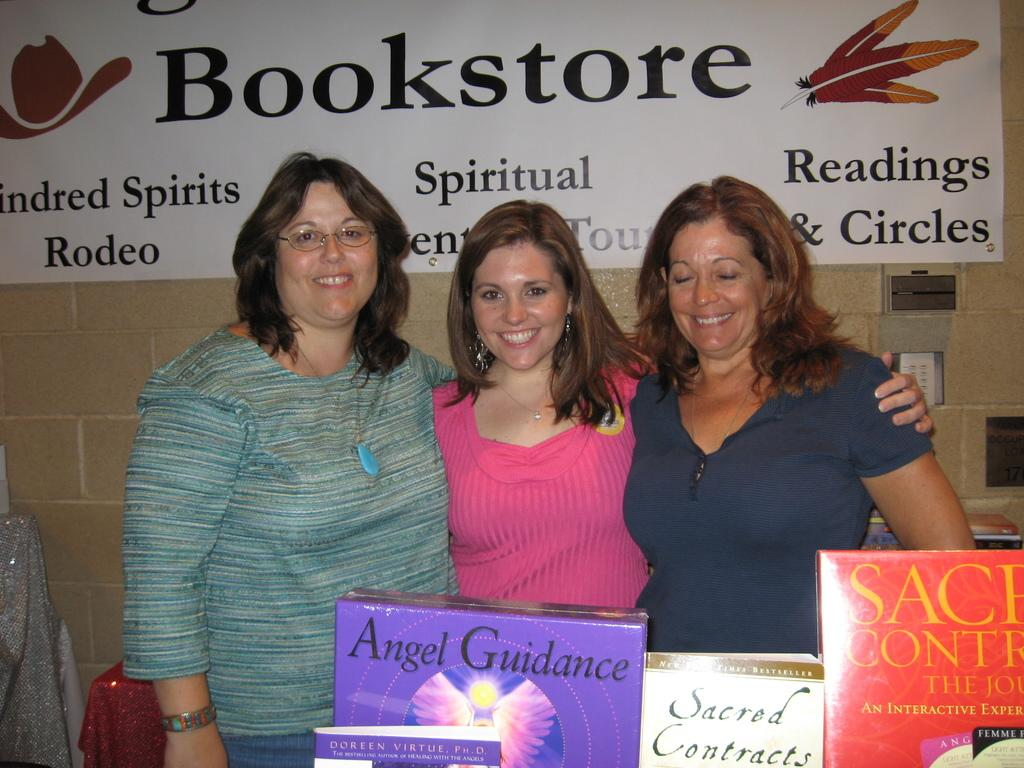How many women are in the image? There are three women in the image. What are the women doing in the image? The women are standing and smiling. What objects are in front of the women? There are boxes in front of the women. What can be seen on the wall in the background of the image? There is a banner on the wall in the background of the image. What type of trees can be seen in the image? There are no trees present in the image. What is the purpose of the meeting in the image? There is no meeting depicted in the image. Can you describe the jellyfish swimming in the background of the image? There are no jellyfish present in the image. 